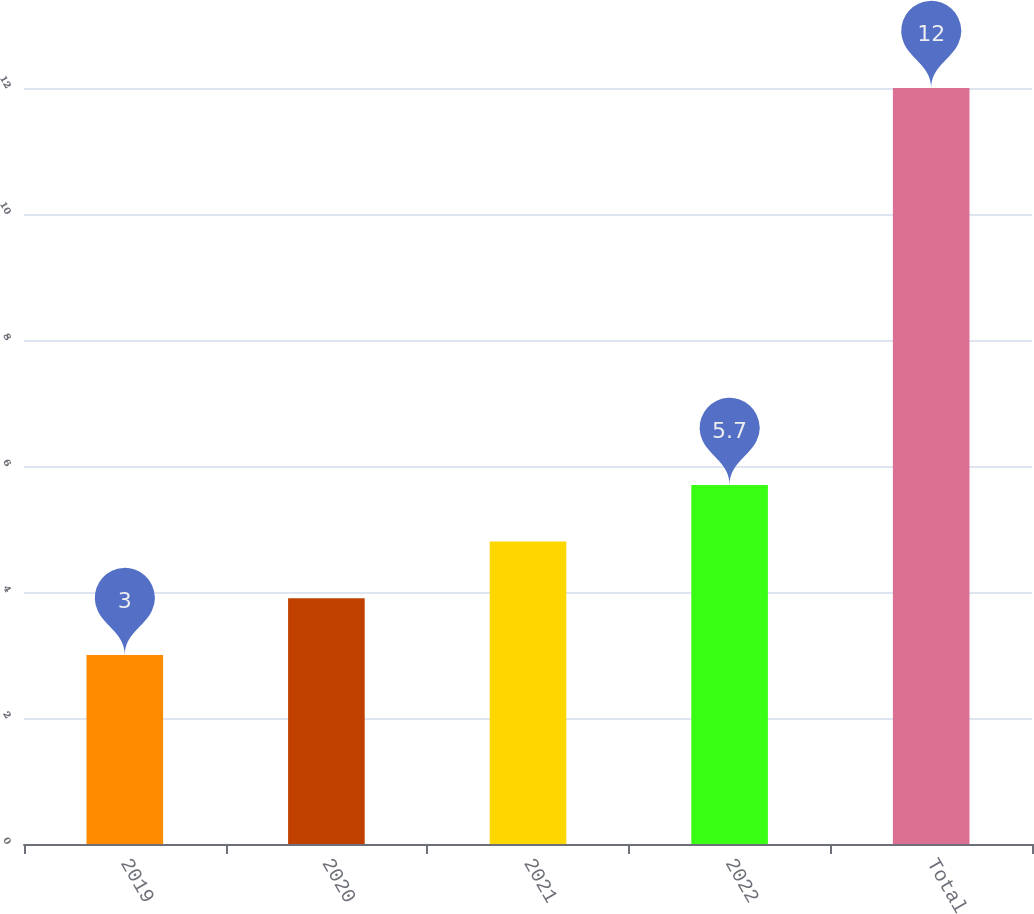Convert chart. <chart><loc_0><loc_0><loc_500><loc_500><bar_chart><fcel>2019<fcel>2020<fcel>2021<fcel>2022<fcel>Total<nl><fcel>3<fcel>3.9<fcel>4.8<fcel>5.7<fcel>12<nl></chart> 